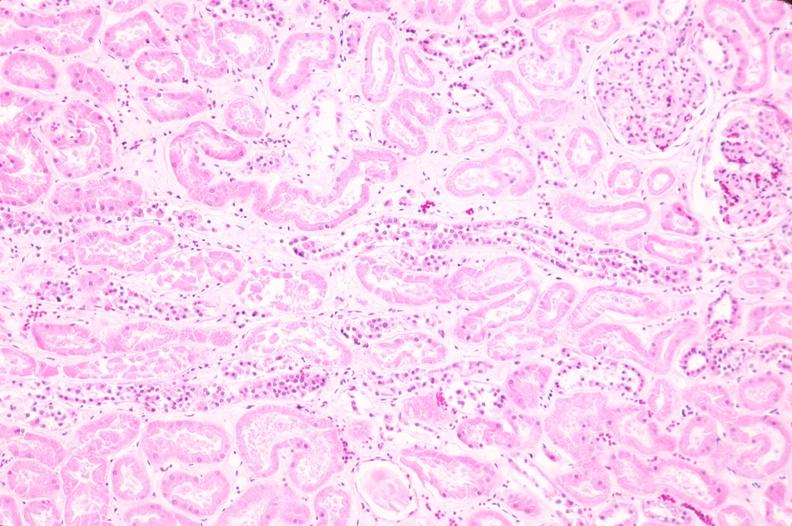does this image show kidney, acute tubular necrosis?
Answer the question using a single word or phrase. Yes 